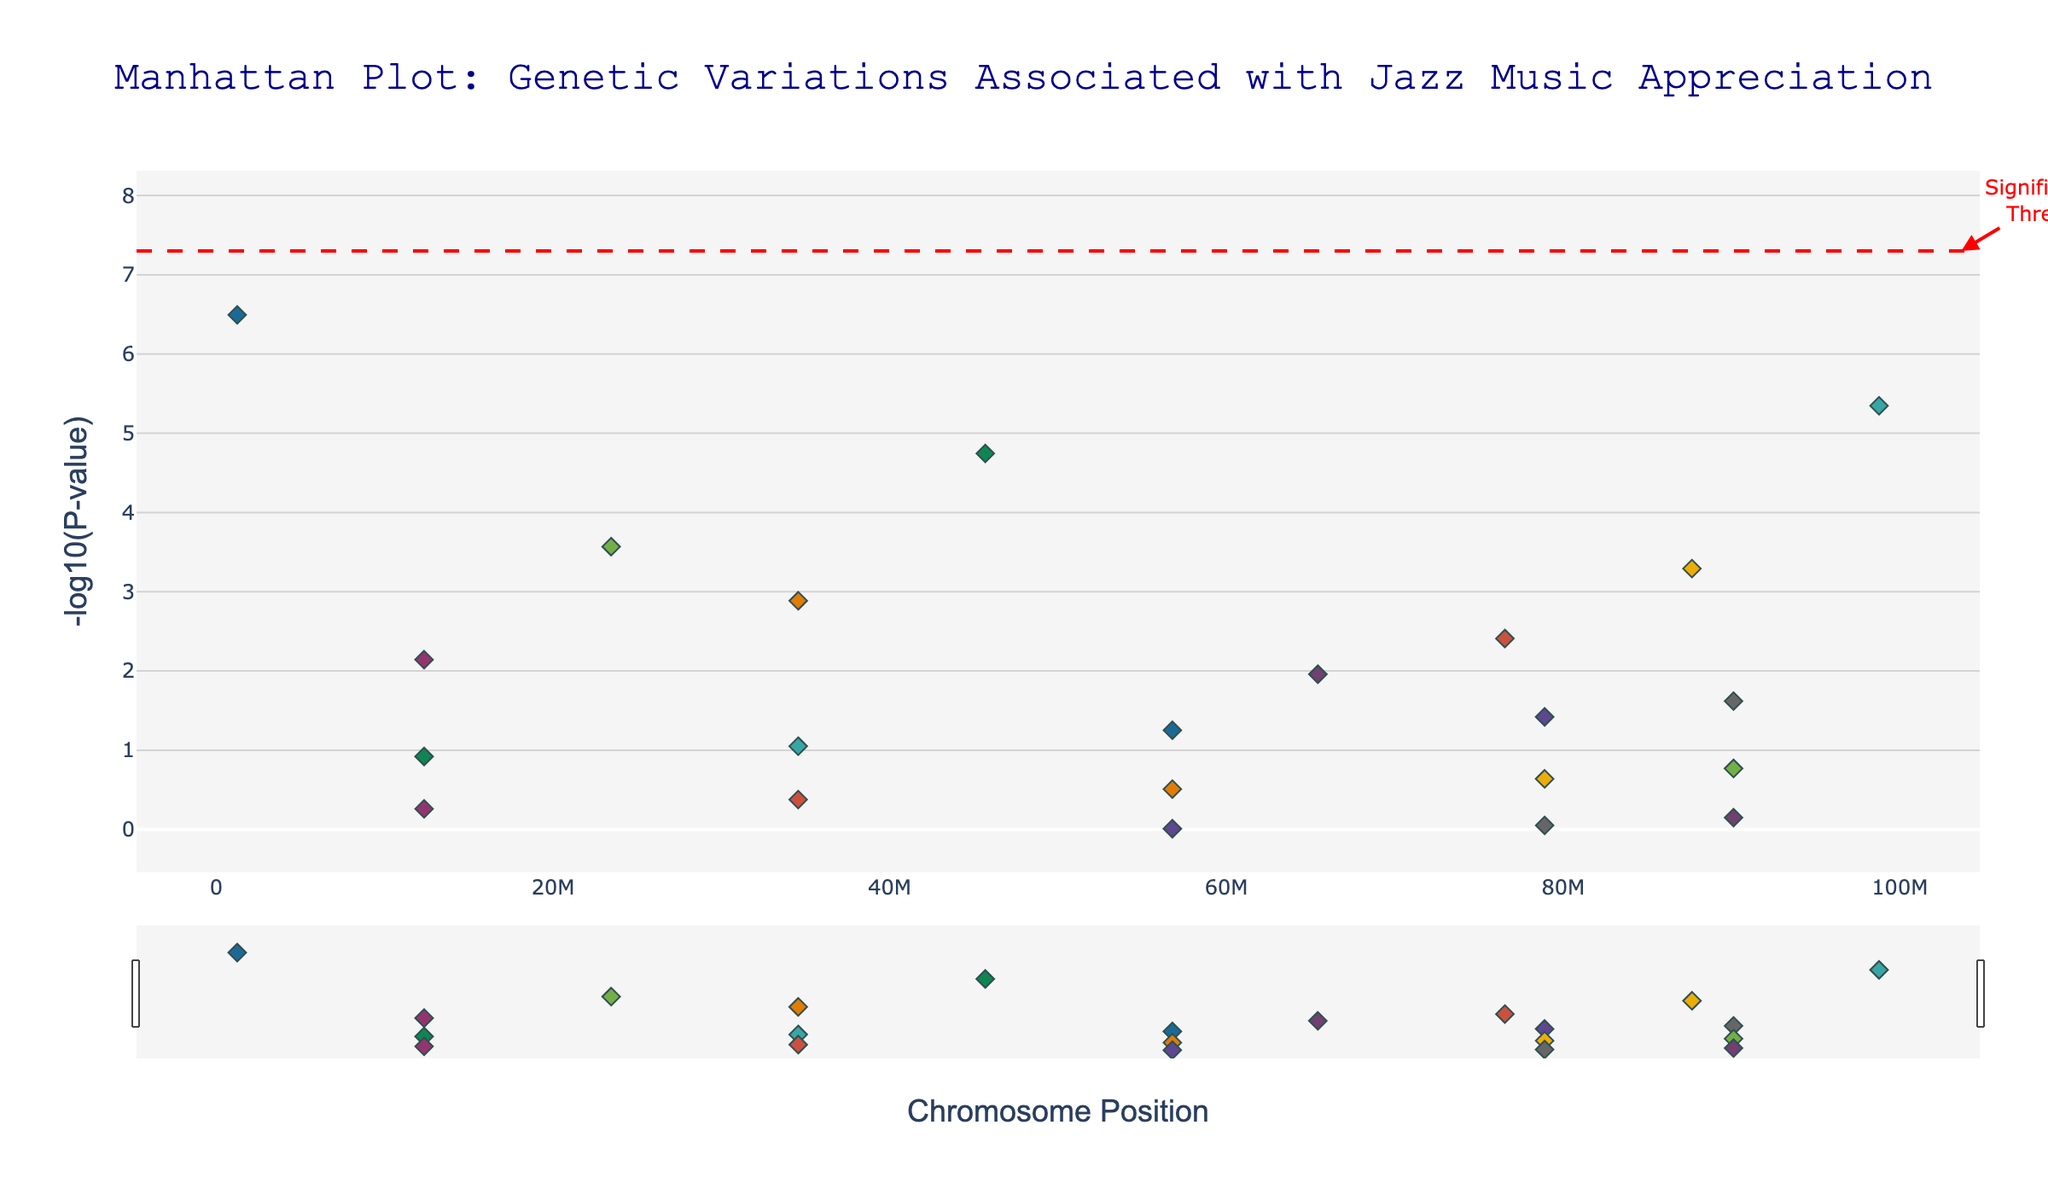What is the title of the figure? The title is located at the top of the figure, usually in bold or larger font. It provides a summary of what the plot represents.
Answer: Manhattan Plot: Genetic Variations Associated with Jazz Music Appreciation Which SNP has the lowest P-value? The lowest P-value corresponds to the highest -log10(P-value). On the plot, locate the highest point along the y-axis and read the SNP label from the hover text or marker.
Answer: rs2734836 What threshold is marked by the horizontal red dashed line? The horizontal red dashed line represents the significance threshold, which is -log10(5e-8). This value is generally used to indicate the level below which the genetic variant is considered significant.
Answer: -log10(5e-8) How many loci are above the significance threshold? Count the number of data points (loci) that are above the horizontal red dashed line, indicating they are statistically significant.
Answer: 1 Which gene corresponds to the SNP at the highest chromosomal position on Chromosome 7? Identify the trace corresponding to Chromosome 7 using the plot legend. Then, find the highest chromosomal position within this trace and read the SNP's gene label from the hover text.
Answer: HTR2A How does the significance of the SNP associated with the gene AVPR1A compare to that associated with TPH2? Locate the SNPs for AVPR1A and TPH2 on the plot. Compare their -log10(P-value) by observing which point is higher on the plot. Higher points indicate more significant values.
Answer: AVPR1A has a higher significance than TPH2 Which chromosome has the highest number of data points? Count the markers (data points) for each chromosome by observing their unique colors on the plot. Determine the chromosome that appears most frequently.
Answer: Chromosome 1 What is the range of -log10(P-values) represented in the plot? The range is found by noting the smallest and largest -log10(P-values) on the y-axis. Identify the corresponding values by looking at the lowest and highest points indicated on the plot.
Answer: 0 to about 6.5 Between which chromosome positions do most loci on Chromosome 4 fall? Focus on the trace corresponding to Chromosome 4. Identify the start and end positions where most of the markers for Chromosome 4 are concentrated.
Answer: Approximately between postitions 23,000,000 and 24,000,000 Which genes are associated with SNPs on Chromosome 1 and have -log10(P-values) above 2? Identify the SNPs on Trace 1 (Chromosome 1) that are above the y-axis value of 2. Then, read the gene labels from these SNPs from the hover text.
Answer: FOXP2 